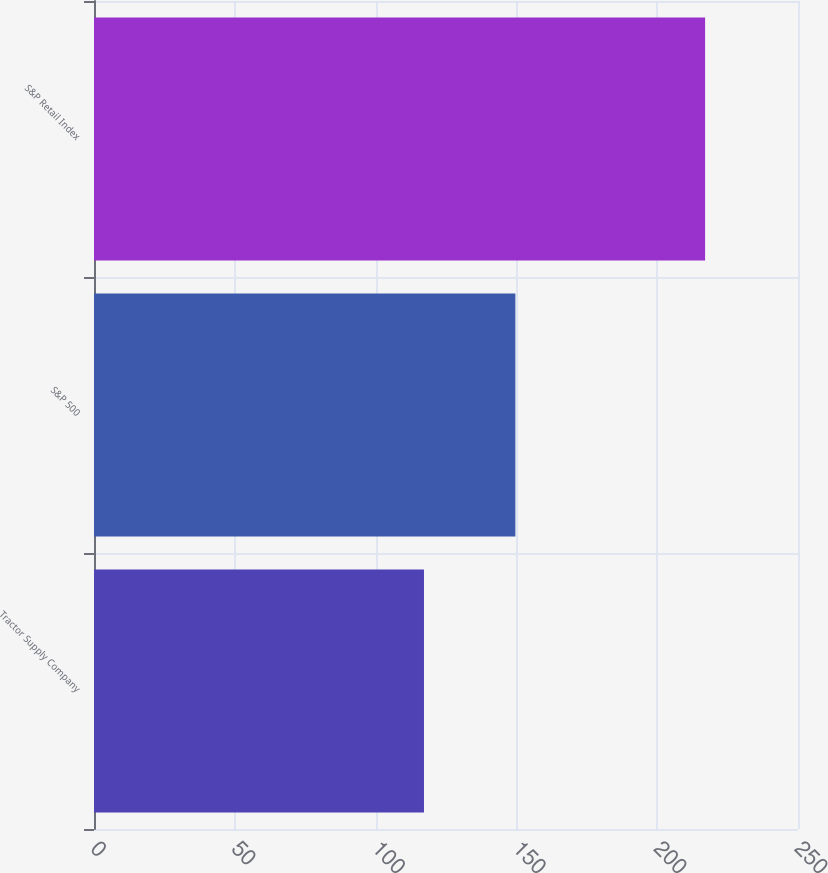<chart> <loc_0><loc_0><loc_500><loc_500><bar_chart><fcel>Tractor Supply Company<fcel>S&P 500<fcel>S&P Retail Index<nl><fcel>117.18<fcel>149.63<fcel>217.01<nl></chart> 